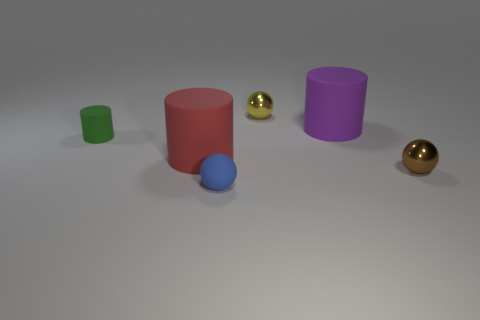The large thing that is left of the ball that is in front of the small brown object is what color?
Make the answer very short. Red. There is a sphere that is in front of the yellow thing and to the right of the small blue sphere; how big is it?
Give a very brief answer. Small. Do the yellow object and the tiny rubber object to the right of the tiny green cylinder have the same shape?
Make the answer very short. Yes. What number of tiny metallic things are in front of the large purple matte cylinder?
Provide a succinct answer. 1. There is a metallic thing that is in front of the yellow metal ball; is it the same shape as the green object?
Keep it short and to the point. No. What color is the small object on the left side of the large red matte cylinder?
Keep it short and to the point. Green. What is the shape of the red object that is the same material as the small green cylinder?
Offer a terse response. Cylinder. Are there any other things that are the same color as the matte sphere?
Your answer should be compact. No. Is the number of objects to the left of the small yellow thing greater than the number of tiny metal spheres to the right of the brown object?
Offer a terse response. Yes. How many cylinders have the same size as the brown sphere?
Ensure brevity in your answer.  1. 